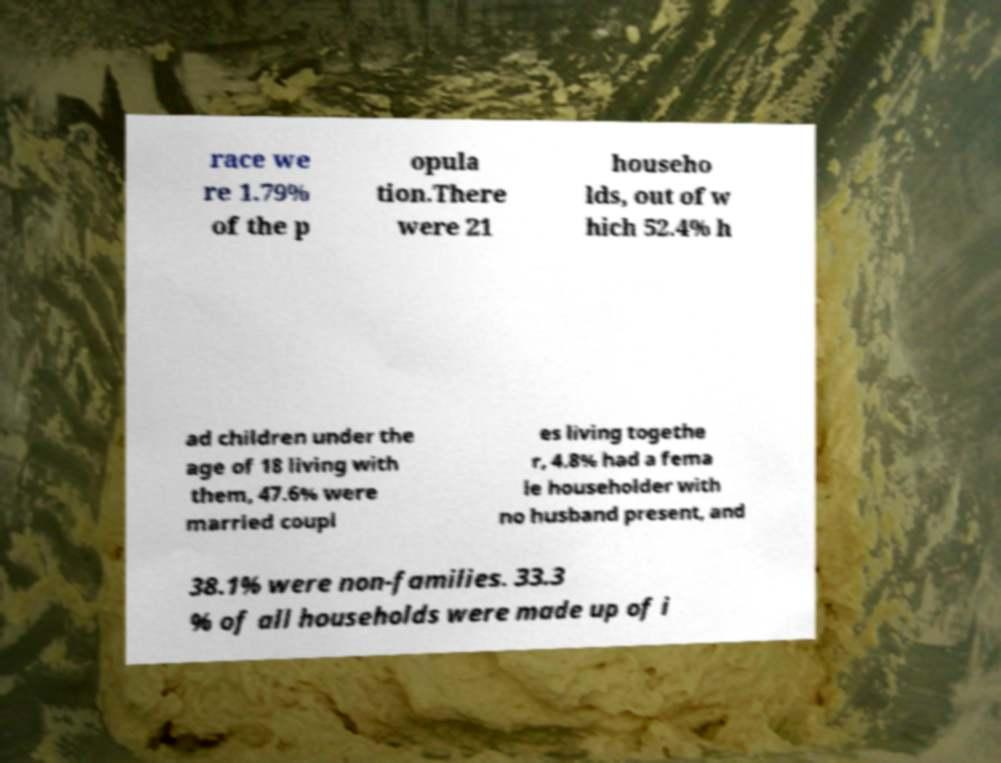Could you extract and type out the text from this image? race we re 1.79% of the p opula tion.There were 21 househo lds, out of w hich 52.4% h ad children under the age of 18 living with them, 47.6% were married coupl es living togethe r, 4.8% had a fema le householder with no husband present, and 38.1% were non-families. 33.3 % of all households were made up of i 